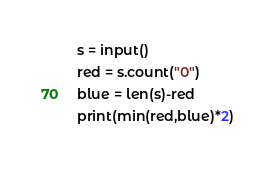Convert code to text. <code><loc_0><loc_0><loc_500><loc_500><_Python_>s = input()
red = s.count("0")
blue = len(s)-red
print(min(red,blue)*2)</code> 